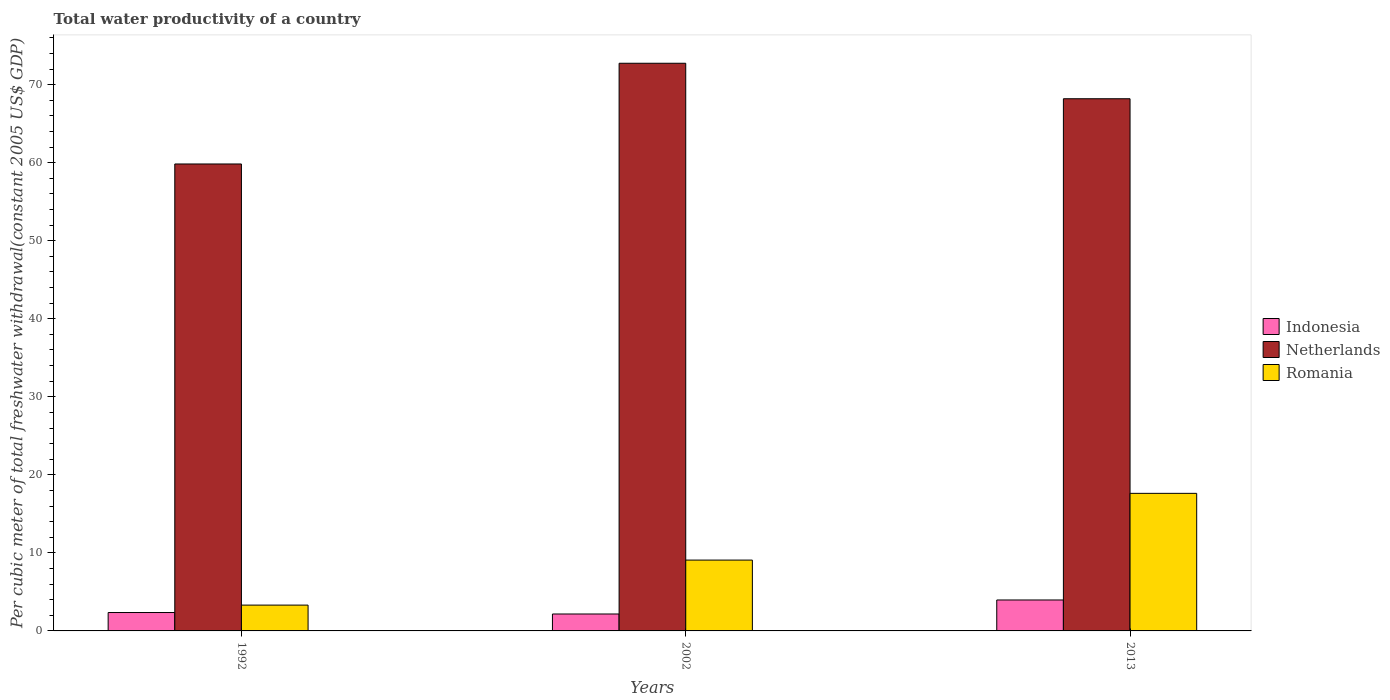How many different coloured bars are there?
Give a very brief answer. 3. How many bars are there on the 1st tick from the left?
Offer a very short reply. 3. How many bars are there on the 1st tick from the right?
Your answer should be compact. 3. In how many cases, is the number of bars for a given year not equal to the number of legend labels?
Ensure brevity in your answer.  0. What is the total water productivity in Romania in 2013?
Offer a terse response. 17.63. Across all years, what is the maximum total water productivity in Netherlands?
Your answer should be compact. 72.74. Across all years, what is the minimum total water productivity in Indonesia?
Make the answer very short. 2.17. In which year was the total water productivity in Netherlands maximum?
Your answer should be compact. 2002. In which year was the total water productivity in Indonesia minimum?
Offer a terse response. 2002. What is the total total water productivity in Indonesia in the graph?
Provide a succinct answer. 8.49. What is the difference between the total water productivity in Indonesia in 1992 and that in 2002?
Your answer should be compact. 0.19. What is the difference between the total water productivity in Romania in 2002 and the total water productivity in Indonesia in 2013?
Provide a short and direct response. 5.11. What is the average total water productivity in Romania per year?
Make the answer very short. 10. In the year 2002, what is the difference between the total water productivity in Romania and total water productivity in Netherlands?
Provide a short and direct response. -63.66. What is the ratio of the total water productivity in Netherlands in 1992 to that in 2013?
Your answer should be compact. 0.88. Is the total water productivity in Romania in 1992 less than that in 2013?
Make the answer very short. Yes. Is the difference between the total water productivity in Romania in 1992 and 2002 greater than the difference between the total water productivity in Netherlands in 1992 and 2002?
Your answer should be very brief. Yes. What is the difference between the highest and the second highest total water productivity in Romania?
Make the answer very short. 8.55. What is the difference between the highest and the lowest total water productivity in Romania?
Your answer should be very brief. 14.32. In how many years, is the total water productivity in Netherlands greater than the average total water productivity in Netherlands taken over all years?
Your answer should be compact. 2. Is the sum of the total water productivity in Indonesia in 2002 and 2013 greater than the maximum total water productivity in Romania across all years?
Your answer should be compact. No. Is it the case that in every year, the sum of the total water productivity in Netherlands and total water productivity in Romania is greater than the total water productivity in Indonesia?
Offer a terse response. Yes. Are all the bars in the graph horizontal?
Make the answer very short. No. How many years are there in the graph?
Your response must be concise. 3. Are the values on the major ticks of Y-axis written in scientific E-notation?
Your answer should be compact. No. Where does the legend appear in the graph?
Your response must be concise. Center right. How many legend labels are there?
Give a very brief answer. 3. How are the legend labels stacked?
Your answer should be very brief. Vertical. What is the title of the graph?
Offer a very short reply. Total water productivity of a country. What is the label or title of the Y-axis?
Ensure brevity in your answer.  Per cubic meter of total freshwater withdrawal(constant 2005 US$ GDP). What is the Per cubic meter of total freshwater withdrawal(constant 2005 US$ GDP) of Indonesia in 1992?
Offer a very short reply. 2.36. What is the Per cubic meter of total freshwater withdrawal(constant 2005 US$ GDP) of Netherlands in 1992?
Your response must be concise. 59.83. What is the Per cubic meter of total freshwater withdrawal(constant 2005 US$ GDP) in Romania in 1992?
Offer a very short reply. 3.31. What is the Per cubic meter of total freshwater withdrawal(constant 2005 US$ GDP) of Indonesia in 2002?
Your answer should be very brief. 2.17. What is the Per cubic meter of total freshwater withdrawal(constant 2005 US$ GDP) in Netherlands in 2002?
Offer a terse response. 72.74. What is the Per cubic meter of total freshwater withdrawal(constant 2005 US$ GDP) of Romania in 2002?
Offer a very short reply. 9.08. What is the Per cubic meter of total freshwater withdrawal(constant 2005 US$ GDP) of Indonesia in 2013?
Your answer should be compact. 3.96. What is the Per cubic meter of total freshwater withdrawal(constant 2005 US$ GDP) in Netherlands in 2013?
Make the answer very short. 68.19. What is the Per cubic meter of total freshwater withdrawal(constant 2005 US$ GDP) in Romania in 2013?
Your answer should be very brief. 17.63. Across all years, what is the maximum Per cubic meter of total freshwater withdrawal(constant 2005 US$ GDP) in Indonesia?
Offer a terse response. 3.96. Across all years, what is the maximum Per cubic meter of total freshwater withdrawal(constant 2005 US$ GDP) of Netherlands?
Offer a very short reply. 72.74. Across all years, what is the maximum Per cubic meter of total freshwater withdrawal(constant 2005 US$ GDP) of Romania?
Your answer should be very brief. 17.63. Across all years, what is the minimum Per cubic meter of total freshwater withdrawal(constant 2005 US$ GDP) in Indonesia?
Ensure brevity in your answer.  2.17. Across all years, what is the minimum Per cubic meter of total freshwater withdrawal(constant 2005 US$ GDP) of Netherlands?
Make the answer very short. 59.83. Across all years, what is the minimum Per cubic meter of total freshwater withdrawal(constant 2005 US$ GDP) of Romania?
Provide a short and direct response. 3.31. What is the total Per cubic meter of total freshwater withdrawal(constant 2005 US$ GDP) of Indonesia in the graph?
Offer a terse response. 8.49. What is the total Per cubic meter of total freshwater withdrawal(constant 2005 US$ GDP) in Netherlands in the graph?
Your response must be concise. 200.76. What is the total Per cubic meter of total freshwater withdrawal(constant 2005 US$ GDP) of Romania in the graph?
Provide a succinct answer. 30.01. What is the difference between the Per cubic meter of total freshwater withdrawal(constant 2005 US$ GDP) in Indonesia in 1992 and that in 2002?
Provide a succinct answer. 0.19. What is the difference between the Per cubic meter of total freshwater withdrawal(constant 2005 US$ GDP) in Netherlands in 1992 and that in 2002?
Offer a very short reply. -12.91. What is the difference between the Per cubic meter of total freshwater withdrawal(constant 2005 US$ GDP) of Romania in 1992 and that in 2002?
Keep it short and to the point. -5.77. What is the difference between the Per cubic meter of total freshwater withdrawal(constant 2005 US$ GDP) of Indonesia in 1992 and that in 2013?
Keep it short and to the point. -1.61. What is the difference between the Per cubic meter of total freshwater withdrawal(constant 2005 US$ GDP) in Netherlands in 1992 and that in 2013?
Offer a very short reply. -8.36. What is the difference between the Per cubic meter of total freshwater withdrawal(constant 2005 US$ GDP) in Romania in 1992 and that in 2013?
Offer a very short reply. -14.32. What is the difference between the Per cubic meter of total freshwater withdrawal(constant 2005 US$ GDP) of Indonesia in 2002 and that in 2013?
Your response must be concise. -1.79. What is the difference between the Per cubic meter of total freshwater withdrawal(constant 2005 US$ GDP) of Netherlands in 2002 and that in 2013?
Keep it short and to the point. 4.55. What is the difference between the Per cubic meter of total freshwater withdrawal(constant 2005 US$ GDP) in Romania in 2002 and that in 2013?
Make the answer very short. -8.55. What is the difference between the Per cubic meter of total freshwater withdrawal(constant 2005 US$ GDP) of Indonesia in 1992 and the Per cubic meter of total freshwater withdrawal(constant 2005 US$ GDP) of Netherlands in 2002?
Provide a short and direct response. -70.38. What is the difference between the Per cubic meter of total freshwater withdrawal(constant 2005 US$ GDP) of Indonesia in 1992 and the Per cubic meter of total freshwater withdrawal(constant 2005 US$ GDP) of Romania in 2002?
Provide a short and direct response. -6.72. What is the difference between the Per cubic meter of total freshwater withdrawal(constant 2005 US$ GDP) in Netherlands in 1992 and the Per cubic meter of total freshwater withdrawal(constant 2005 US$ GDP) in Romania in 2002?
Give a very brief answer. 50.76. What is the difference between the Per cubic meter of total freshwater withdrawal(constant 2005 US$ GDP) in Indonesia in 1992 and the Per cubic meter of total freshwater withdrawal(constant 2005 US$ GDP) in Netherlands in 2013?
Ensure brevity in your answer.  -65.83. What is the difference between the Per cubic meter of total freshwater withdrawal(constant 2005 US$ GDP) in Indonesia in 1992 and the Per cubic meter of total freshwater withdrawal(constant 2005 US$ GDP) in Romania in 2013?
Your response must be concise. -15.27. What is the difference between the Per cubic meter of total freshwater withdrawal(constant 2005 US$ GDP) of Netherlands in 1992 and the Per cubic meter of total freshwater withdrawal(constant 2005 US$ GDP) of Romania in 2013?
Ensure brevity in your answer.  42.21. What is the difference between the Per cubic meter of total freshwater withdrawal(constant 2005 US$ GDP) of Indonesia in 2002 and the Per cubic meter of total freshwater withdrawal(constant 2005 US$ GDP) of Netherlands in 2013?
Your response must be concise. -66.02. What is the difference between the Per cubic meter of total freshwater withdrawal(constant 2005 US$ GDP) in Indonesia in 2002 and the Per cubic meter of total freshwater withdrawal(constant 2005 US$ GDP) in Romania in 2013?
Your answer should be compact. -15.46. What is the difference between the Per cubic meter of total freshwater withdrawal(constant 2005 US$ GDP) of Netherlands in 2002 and the Per cubic meter of total freshwater withdrawal(constant 2005 US$ GDP) of Romania in 2013?
Make the answer very short. 55.11. What is the average Per cubic meter of total freshwater withdrawal(constant 2005 US$ GDP) of Indonesia per year?
Give a very brief answer. 2.83. What is the average Per cubic meter of total freshwater withdrawal(constant 2005 US$ GDP) in Netherlands per year?
Your answer should be compact. 66.92. What is the average Per cubic meter of total freshwater withdrawal(constant 2005 US$ GDP) in Romania per year?
Ensure brevity in your answer.  10. In the year 1992, what is the difference between the Per cubic meter of total freshwater withdrawal(constant 2005 US$ GDP) of Indonesia and Per cubic meter of total freshwater withdrawal(constant 2005 US$ GDP) of Netherlands?
Ensure brevity in your answer.  -57.48. In the year 1992, what is the difference between the Per cubic meter of total freshwater withdrawal(constant 2005 US$ GDP) in Indonesia and Per cubic meter of total freshwater withdrawal(constant 2005 US$ GDP) in Romania?
Ensure brevity in your answer.  -0.95. In the year 1992, what is the difference between the Per cubic meter of total freshwater withdrawal(constant 2005 US$ GDP) in Netherlands and Per cubic meter of total freshwater withdrawal(constant 2005 US$ GDP) in Romania?
Your answer should be compact. 56.53. In the year 2002, what is the difference between the Per cubic meter of total freshwater withdrawal(constant 2005 US$ GDP) in Indonesia and Per cubic meter of total freshwater withdrawal(constant 2005 US$ GDP) in Netherlands?
Your response must be concise. -70.57. In the year 2002, what is the difference between the Per cubic meter of total freshwater withdrawal(constant 2005 US$ GDP) of Indonesia and Per cubic meter of total freshwater withdrawal(constant 2005 US$ GDP) of Romania?
Make the answer very short. -6.91. In the year 2002, what is the difference between the Per cubic meter of total freshwater withdrawal(constant 2005 US$ GDP) in Netherlands and Per cubic meter of total freshwater withdrawal(constant 2005 US$ GDP) in Romania?
Provide a short and direct response. 63.66. In the year 2013, what is the difference between the Per cubic meter of total freshwater withdrawal(constant 2005 US$ GDP) in Indonesia and Per cubic meter of total freshwater withdrawal(constant 2005 US$ GDP) in Netherlands?
Provide a succinct answer. -64.23. In the year 2013, what is the difference between the Per cubic meter of total freshwater withdrawal(constant 2005 US$ GDP) in Indonesia and Per cubic meter of total freshwater withdrawal(constant 2005 US$ GDP) in Romania?
Your answer should be very brief. -13.66. In the year 2013, what is the difference between the Per cubic meter of total freshwater withdrawal(constant 2005 US$ GDP) of Netherlands and Per cubic meter of total freshwater withdrawal(constant 2005 US$ GDP) of Romania?
Provide a succinct answer. 50.56. What is the ratio of the Per cubic meter of total freshwater withdrawal(constant 2005 US$ GDP) of Indonesia in 1992 to that in 2002?
Make the answer very short. 1.09. What is the ratio of the Per cubic meter of total freshwater withdrawal(constant 2005 US$ GDP) of Netherlands in 1992 to that in 2002?
Keep it short and to the point. 0.82. What is the ratio of the Per cubic meter of total freshwater withdrawal(constant 2005 US$ GDP) in Romania in 1992 to that in 2002?
Ensure brevity in your answer.  0.36. What is the ratio of the Per cubic meter of total freshwater withdrawal(constant 2005 US$ GDP) of Indonesia in 1992 to that in 2013?
Your answer should be very brief. 0.59. What is the ratio of the Per cubic meter of total freshwater withdrawal(constant 2005 US$ GDP) in Netherlands in 1992 to that in 2013?
Your answer should be compact. 0.88. What is the ratio of the Per cubic meter of total freshwater withdrawal(constant 2005 US$ GDP) in Romania in 1992 to that in 2013?
Provide a succinct answer. 0.19. What is the ratio of the Per cubic meter of total freshwater withdrawal(constant 2005 US$ GDP) of Indonesia in 2002 to that in 2013?
Make the answer very short. 0.55. What is the ratio of the Per cubic meter of total freshwater withdrawal(constant 2005 US$ GDP) in Netherlands in 2002 to that in 2013?
Provide a short and direct response. 1.07. What is the ratio of the Per cubic meter of total freshwater withdrawal(constant 2005 US$ GDP) of Romania in 2002 to that in 2013?
Give a very brief answer. 0.51. What is the difference between the highest and the second highest Per cubic meter of total freshwater withdrawal(constant 2005 US$ GDP) in Indonesia?
Make the answer very short. 1.61. What is the difference between the highest and the second highest Per cubic meter of total freshwater withdrawal(constant 2005 US$ GDP) in Netherlands?
Give a very brief answer. 4.55. What is the difference between the highest and the second highest Per cubic meter of total freshwater withdrawal(constant 2005 US$ GDP) in Romania?
Your answer should be compact. 8.55. What is the difference between the highest and the lowest Per cubic meter of total freshwater withdrawal(constant 2005 US$ GDP) in Indonesia?
Make the answer very short. 1.79. What is the difference between the highest and the lowest Per cubic meter of total freshwater withdrawal(constant 2005 US$ GDP) of Netherlands?
Provide a succinct answer. 12.91. What is the difference between the highest and the lowest Per cubic meter of total freshwater withdrawal(constant 2005 US$ GDP) of Romania?
Offer a very short reply. 14.32. 